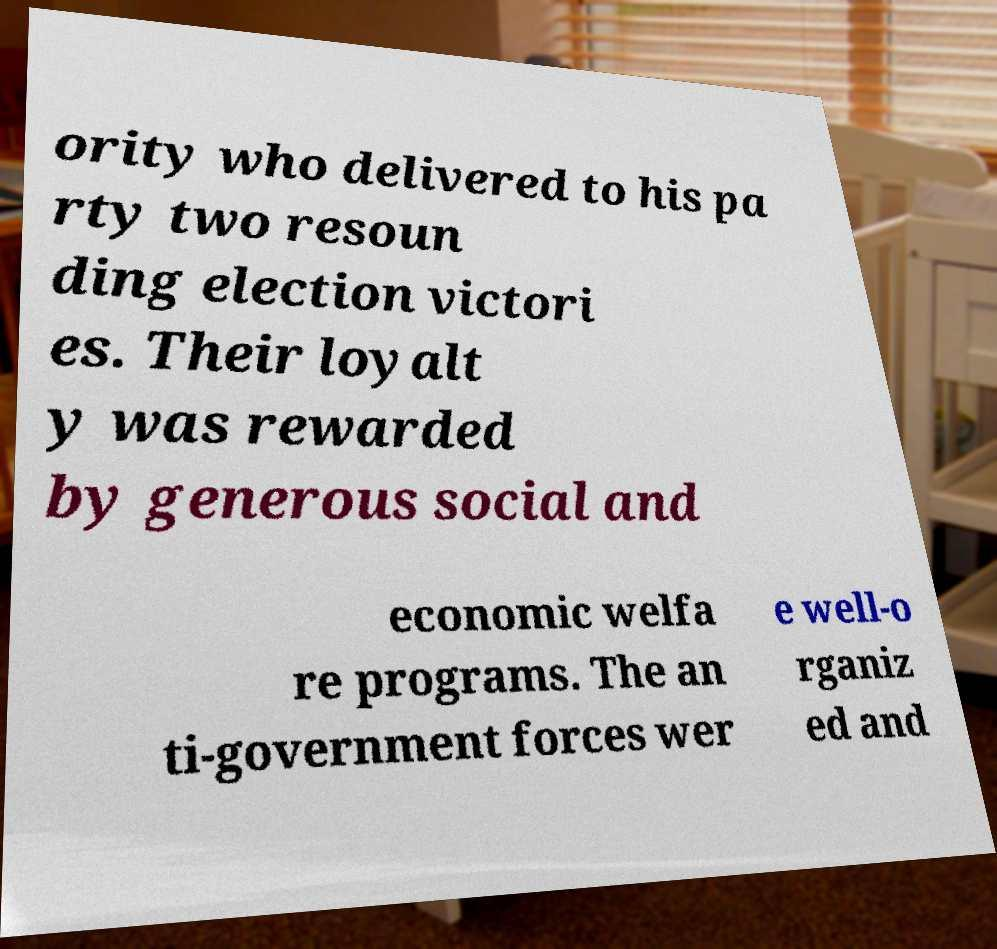Please identify and transcribe the text found in this image. ority who delivered to his pa rty two resoun ding election victori es. Their loyalt y was rewarded by generous social and economic welfa re programs. The an ti-government forces wer e well-o rganiz ed and 